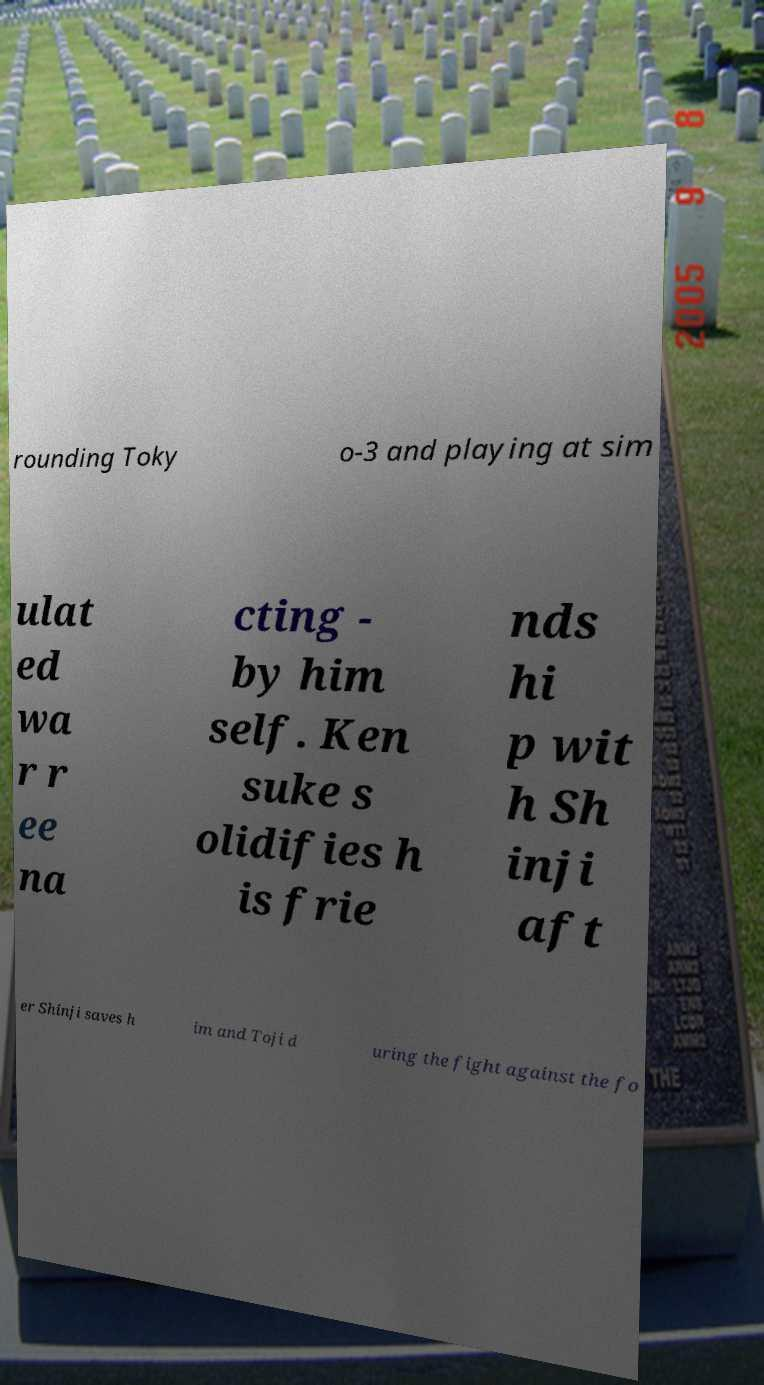What messages or text are displayed in this image? I need them in a readable, typed format. rounding Toky o-3 and playing at sim ulat ed wa r r ee na cting - by him self. Ken suke s olidifies h is frie nds hi p wit h Sh inji aft er Shinji saves h im and Toji d uring the fight against the fo 